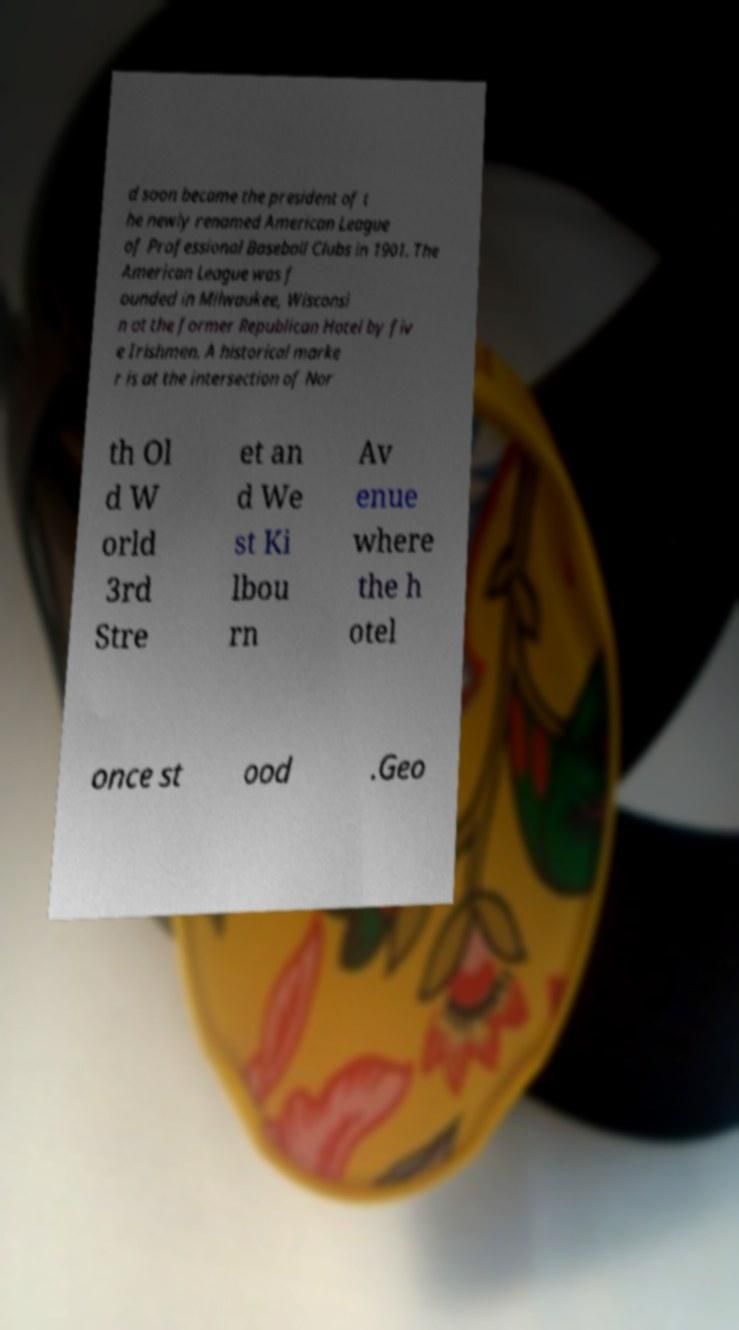Please identify and transcribe the text found in this image. d soon became the president of t he newly renamed American League of Professional Baseball Clubs in 1901. The American League was f ounded in Milwaukee, Wisconsi n at the former Republican Hotel by fiv e Irishmen. A historical marke r is at the intersection of Nor th Ol d W orld 3rd Stre et an d We st Ki lbou rn Av enue where the h otel once st ood .Geo 